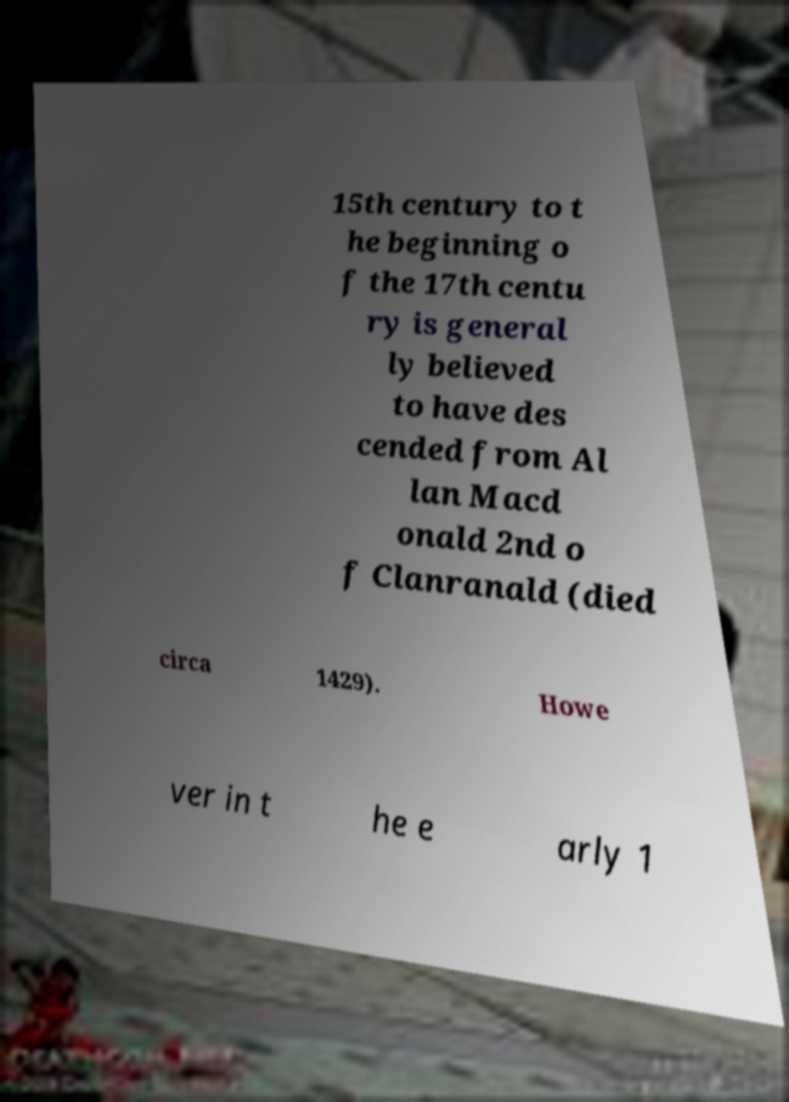What messages or text are displayed in this image? I need them in a readable, typed format. 15th century to t he beginning o f the 17th centu ry is general ly believed to have des cended from Al lan Macd onald 2nd o f Clanranald (died circa 1429). Howe ver in t he e arly 1 